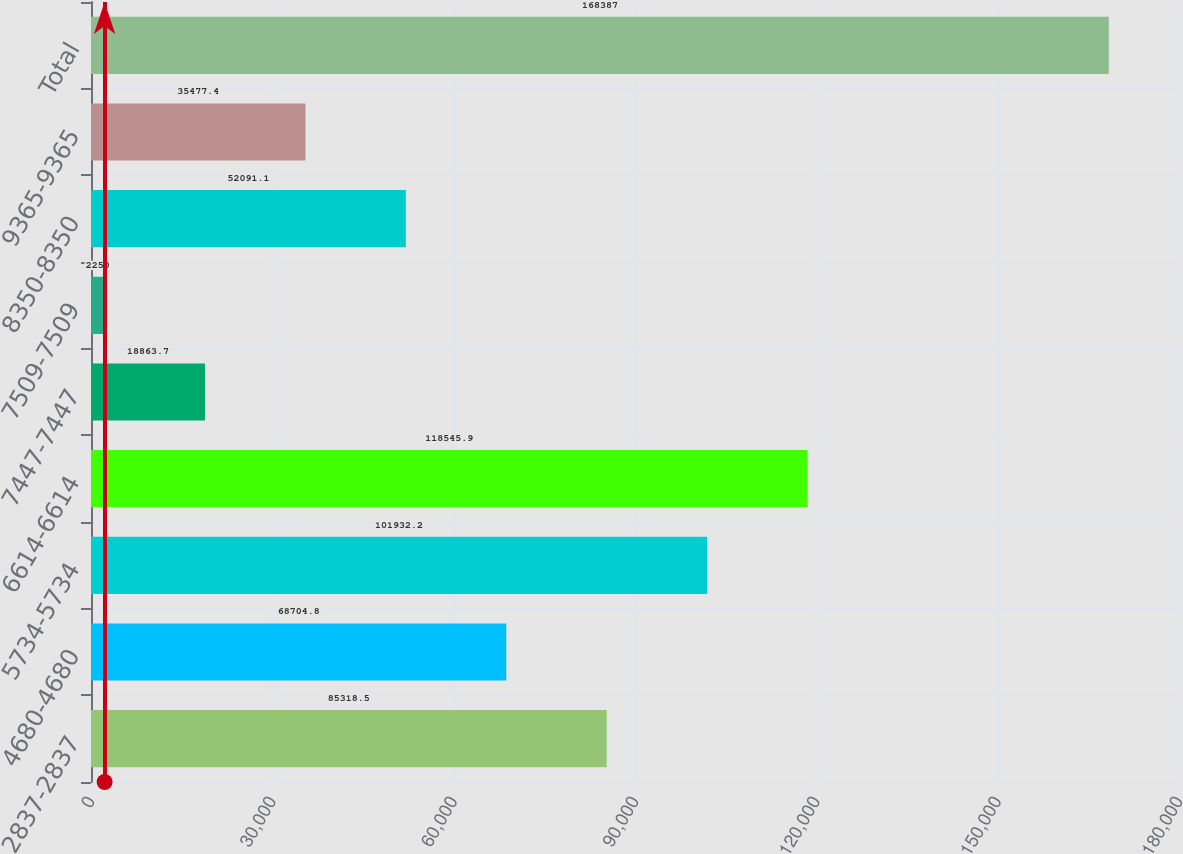<chart> <loc_0><loc_0><loc_500><loc_500><bar_chart><fcel>2837-2837<fcel>4680-4680<fcel>5734-5734<fcel>6614-6614<fcel>7447-7447<fcel>7509-7509<fcel>8350-8350<fcel>9365-9365<fcel>Total<nl><fcel>85318.5<fcel>68704.8<fcel>101932<fcel>118546<fcel>18863.7<fcel>2250<fcel>52091.1<fcel>35477.4<fcel>168387<nl></chart> 